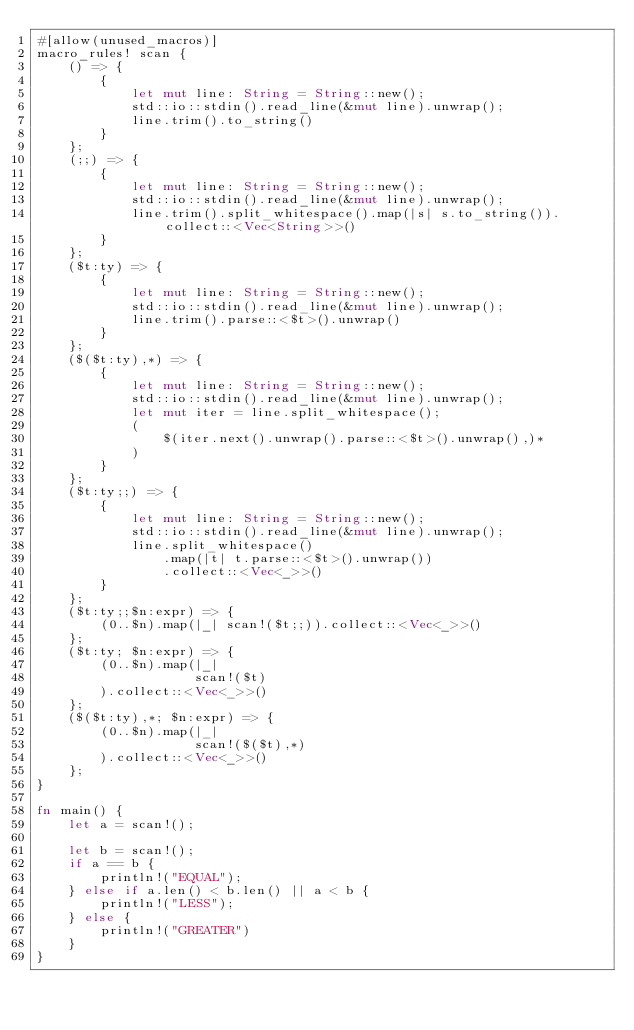Convert code to text. <code><loc_0><loc_0><loc_500><loc_500><_Rust_>#[allow(unused_macros)]
macro_rules! scan {
    () => {
        {
            let mut line: String = String::new();
            std::io::stdin().read_line(&mut line).unwrap();
            line.trim().to_string()
        }
    };
    (;;) => {
        {
            let mut line: String = String::new();
            std::io::stdin().read_line(&mut line).unwrap();
            line.trim().split_whitespace().map(|s| s.to_string()).collect::<Vec<String>>()
        }
    };
    ($t:ty) => {
        {
            let mut line: String = String::new();
            std::io::stdin().read_line(&mut line).unwrap();
            line.trim().parse::<$t>().unwrap()
        }
    };
    ($($t:ty),*) => {
        {
            let mut line: String = String::new();
            std::io::stdin().read_line(&mut line).unwrap();
            let mut iter = line.split_whitespace();
            (
                $(iter.next().unwrap().parse::<$t>().unwrap(),)*
            )
        }
    };
    ($t:ty;;) => {
        {
            let mut line: String = String::new();
            std::io::stdin().read_line(&mut line).unwrap();
            line.split_whitespace()
                .map(|t| t.parse::<$t>().unwrap())
                .collect::<Vec<_>>()
        }
    };
    ($t:ty;;$n:expr) => {
        (0..$n).map(|_| scan!($t;;)).collect::<Vec<_>>()
    };
    ($t:ty; $n:expr) => {
        (0..$n).map(|_|
                    scan!($t)
        ).collect::<Vec<_>>()
    };
    ($($t:ty),*; $n:expr) => {
        (0..$n).map(|_|
                    scan!($($t),*)
        ).collect::<Vec<_>>()
    };
}

fn main() {
    let a = scan!();

    let b = scan!();
    if a == b {
        println!("EQUAL");
    } else if a.len() < b.len() || a < b {
        println!("LESS");
    } else {
        println!("GREATER")
    }
}
</code> 